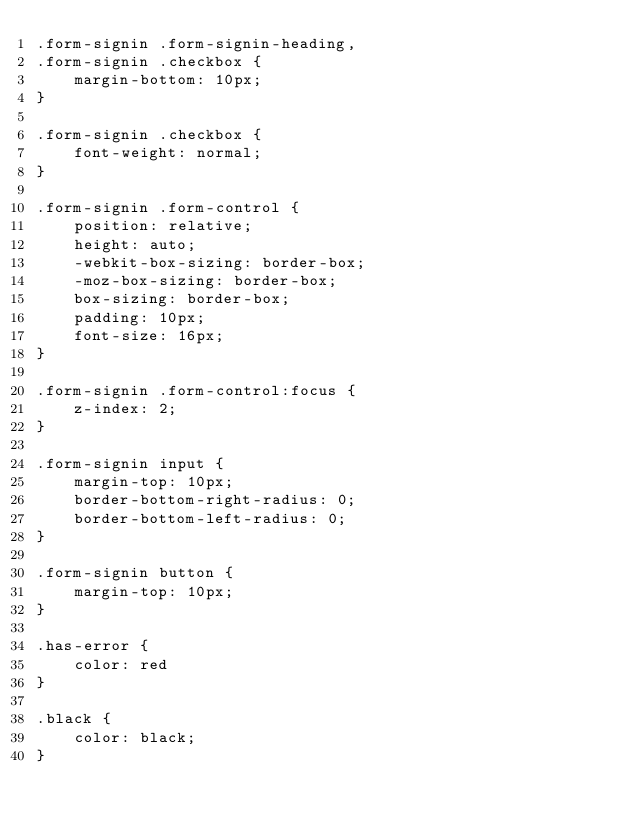Convert code to text. <code><loc_0><loc_0><loc_500><loc_500><_CSS_>.form-signin .form-signin-heading,
.form-signin .checkbox {
    margin-bottom: 10px;
}

.form-signin .checkbox {
    font-weight: normal;
}

.form-signin .form-control {
    position: relative;
    height: auto;
    -webkit-box-sizing: border-box;
    -moz-box-sizing: border-box;
    box-sizing: border-box;
    padding: 10px;
    font-size: 16px;
}

.form-signin .form-control:focus {
    z-index: 2;
}

.form-signin input {
    margin-top: 10px;
    border-bottom-right-radius: 0;
    border-bottom-left-radius: 0;
}

.form-signin button {
    margin-top: 10px;
}

.has-error {
    color: red
}

.black {
    color: black;
}</code> 